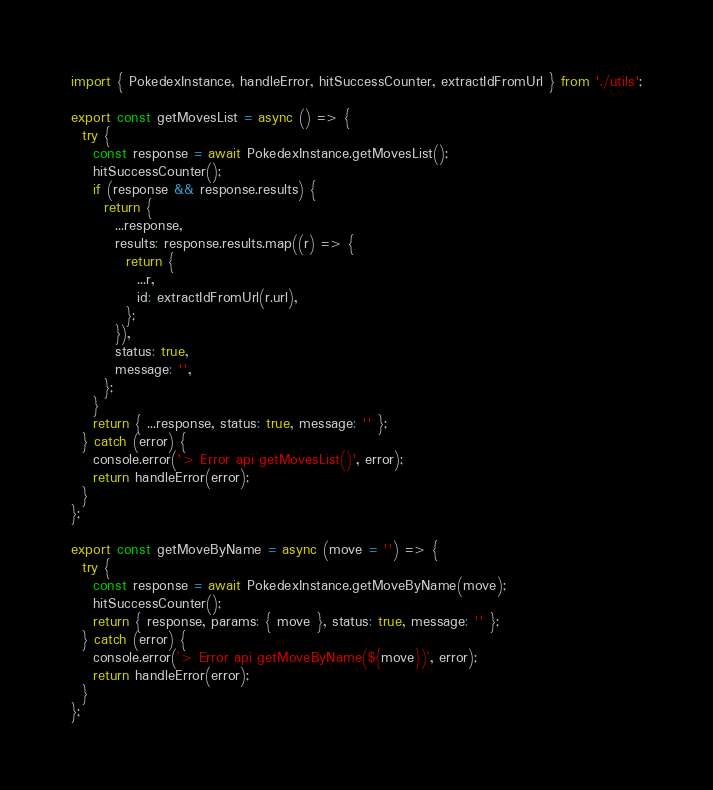<code> <loc_0><loc_0><loc_500><loc_500><_JavaScript_>import { PokedexInstance, handleError, hitSuccessCounter, extractIdFromUrl } from './utils';

export const getMovesList = async () => {
  try {
    const response = await PokedexInstance.getMovesList();
    hitSuccessCounter();
    if (response && response.results) {
      return {
        ...response,
        results: response.results.map((r) => {
          return {
            ...r,
            id: extractIdFromUrl(r.url),
          };
        }),
        status: true,
        message: '',
      };
    }
    return { ...response, status: true, message: '' };
  } catch (error) {
    console.error('> Error api getMovesList()', error);
    return handleError(error);
  }
};

export const getMoveByName = async (move = '') => {
  try {
    const response = await PokedexInstance.getMoveByName(move);
    hitSuccessCounter();
    return { response, params: { move }, status: true, message: '' };
  } catch (error) {
    console.error(`> Error api getMoveByName(${move})`, error);
    return handleError(error);
  }
};
</code> 